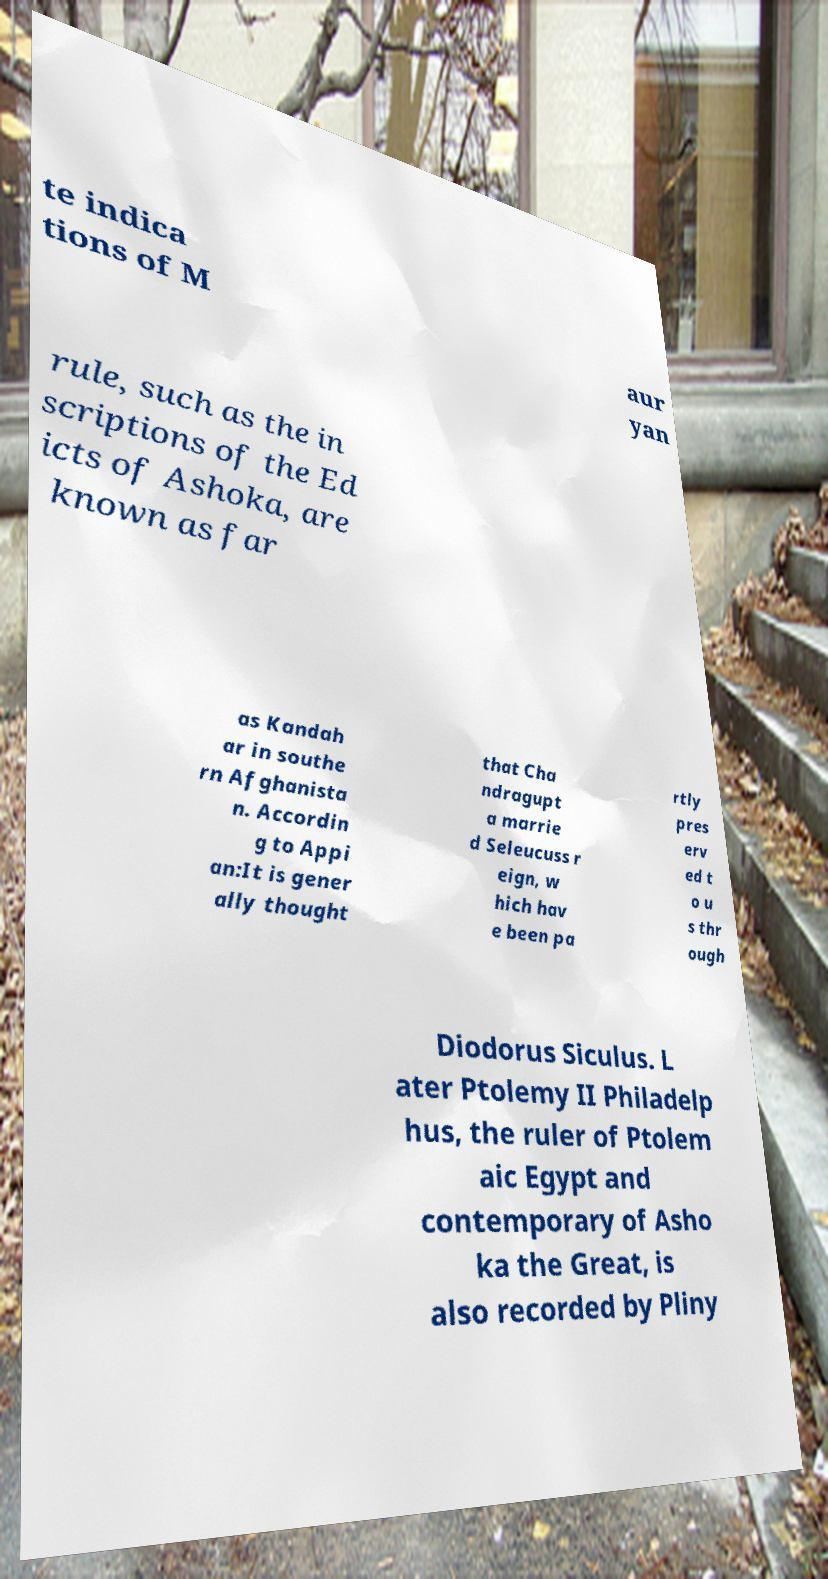There's text embedded in this image that I need extracted. Can you transcribe it verbatim? te indica tions of M aur yan rule, such as the in scriptions of the Ed icts of Ashoka, are known as far as Kandah ar in southe rn Afghanista n. Accordin g to Appi an:It is gener ally thought that Cha ndragupt a marrie d Seleucuss r eign, w hich hav e been pa rtly pres erv ed t o u s thr ough Diodorus Siculus. L ater Ptolemy II Philadelp hus, the ruler of Ptolem aic Egypt and contemporary of Asho ka the Great, is also recorded by Pliny 